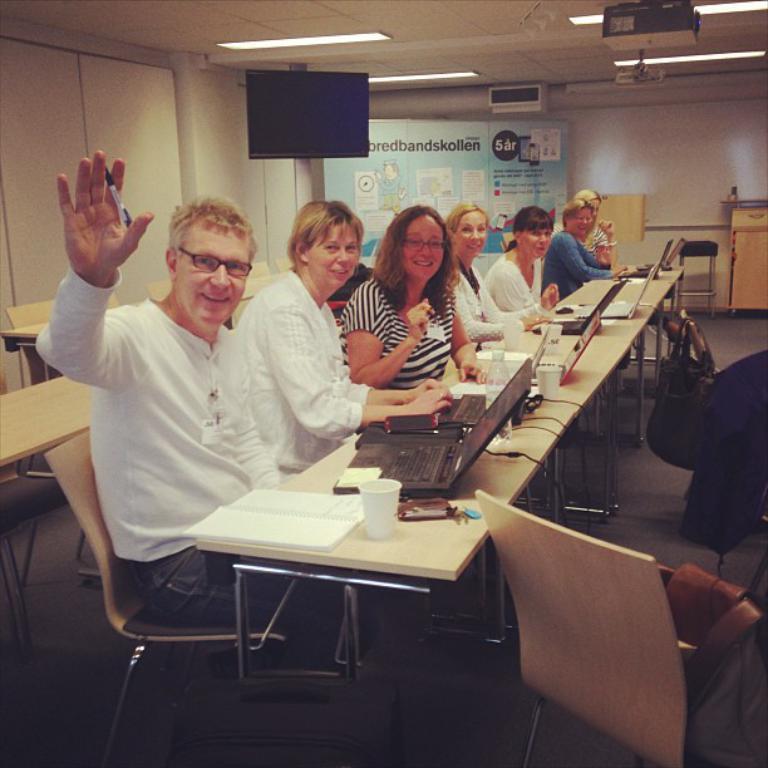Please provide a concise description of this image. In this picture we can see some persons are sitting on the chairs. This is table. On the table there are laptops, books, and glasses. This is floor. Here we can see a screen and these are the lights. On the background there is a wall and this is banner. 